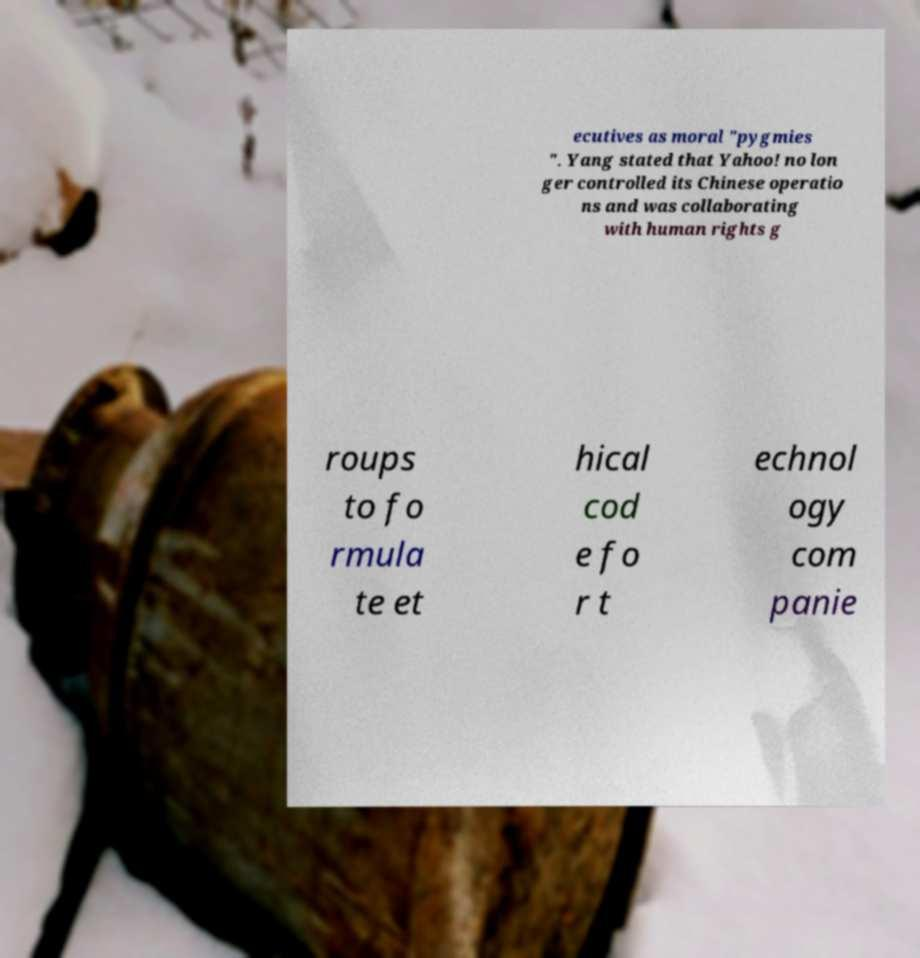I need the written content from this picture converted into text. Can you do that? ecutives as moral "pygmies ". Yang stated that Yahoo! no lon ger controlled its Chinese operatio ns and was collaborating with human rights g roups to fo rmula te et hical cod e fo r t echnol ogy com panie 